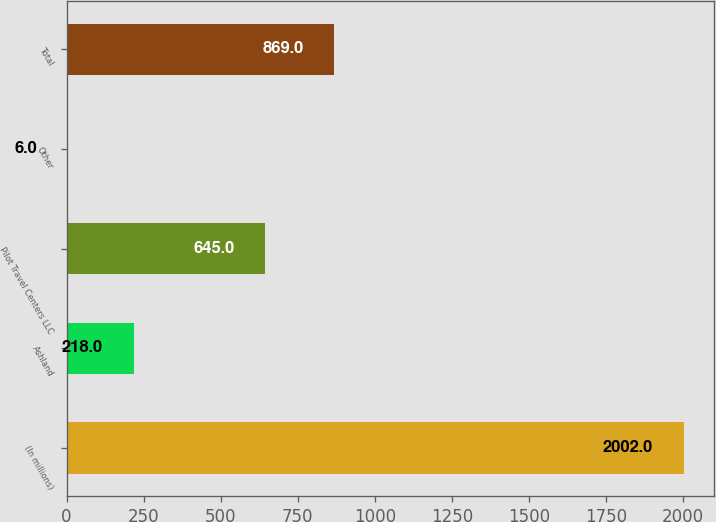Convert chart to OTSL. <chart><loc_0><loc_0><loc_500><loc_500><bar_chart><fcel>(In millions)<fcel>Ashland<fcel>Pilot Travel Centers LLC<fcel>Other<fcel>Total<nl><fcel>2002<fcel>218<fcel>645<fcel>6<fcel>869<nl></chart> 